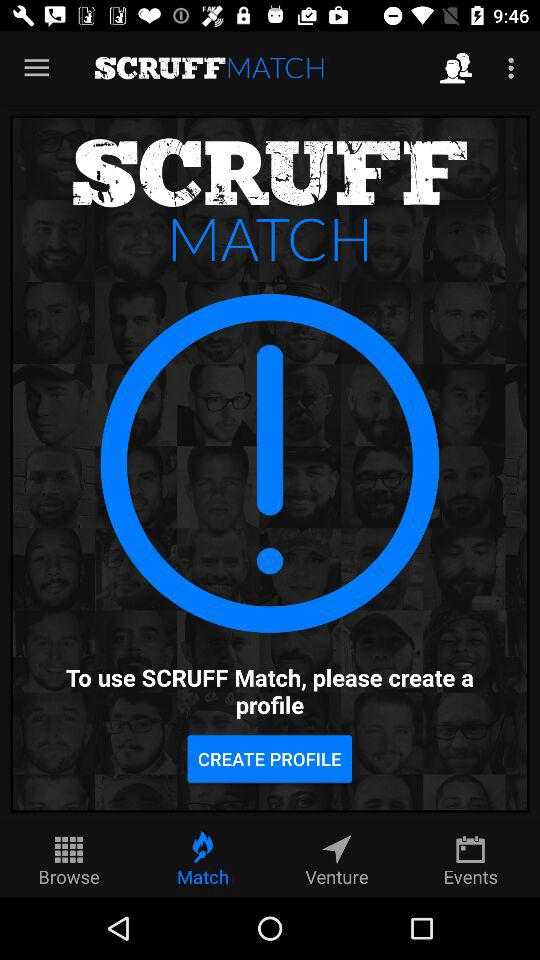Which tab is selected? The selected tab is "Match". 